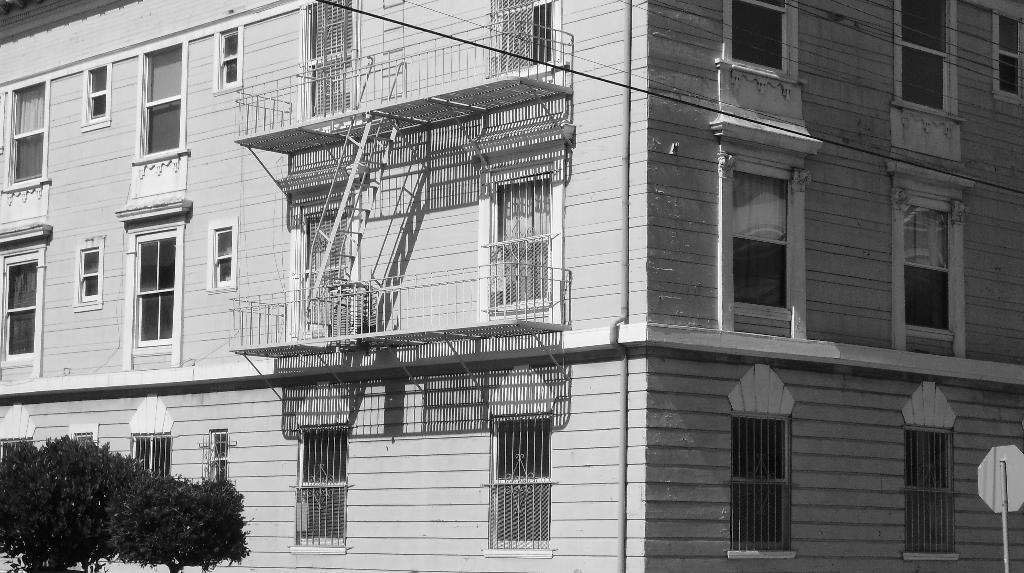What is the color scheme of the image? The image is black and white. What type of structure can be seen in the image? There is a building in the image. What is located on the right side of the image? There is a board on the right side of the image. What type of natural elements are visible in the image? Trees are visible in the left top of the image. What type of grain is being harvested by the lawyer in the image? There is no grain or lawyer present in the image; it features a building, a board, and trees. 